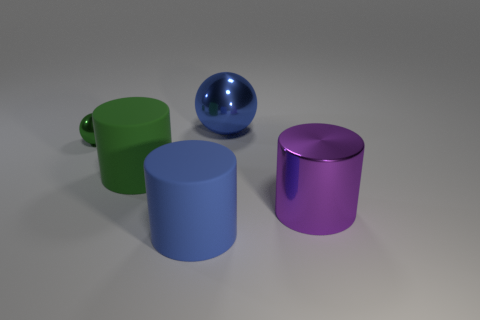Is the large ball the same color as the small metal sphere?
Offer a terse response. No. What material is the thing that is the same color as the large metal ball?
Give a very brief answer. Rubber. The blue shiny thing that is the same size as the metallic cylinder is what shape?
Your answer should be compact. Sphere. What material is the large blue thing that is behind the metal sphere in front of the blue sphere?
Your response must be concise. Metal. Are there the same number of small green metal balls that are to the left of the green shiny object and big purple metallic objects that are behind the large purple metal thing?
Provide a short and direct response. Yes. What number of things are either big blue balls that are to the left of the shiny cylinder or big rubber things in front of the large purple cylinder?
Your answer should be compact. 2. What is the material of the object that is both to the right of the green shiny object and behind the big green object?
Give a very brief answer. Metal. There is a matte cylinder that is in front of the big matte cylinder behind the rubber cylinder that is in front of the green rubber cylinder; what is its size?
Offer a terse response. Large. Is the number of green cylinders greater than the number of cylinders?
Offer a terse response. No. Does the large blue thing in front of the small green shiny sphere have the same material as the large sphere?
Provide a short and direct response. No. 